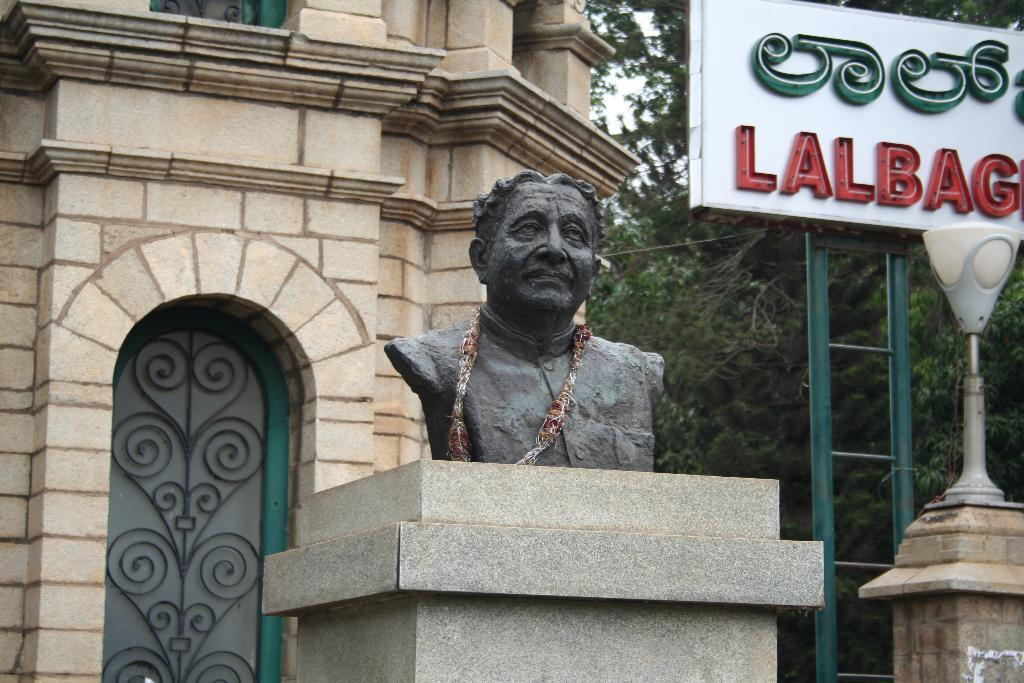What type of structure is present in the image? There is a building in the image. What other natural elements can be seen in the image? There are trees in the image. Is there any text or signage visible in the image? Yes, there is a board with text in the image. What type of lighting is present in the image? There is a pole light in the image. Are there any sculptures or statues in the image? Yes, there is a statue of a man in the image. Can you tell me how many people are playing on the bridge in the image? There is no bridge present in the image, and therefore no one is playing on it. What type of act is the statue performing in the image? The statue is not performing an act; it is a stationary sculpture of a man. 